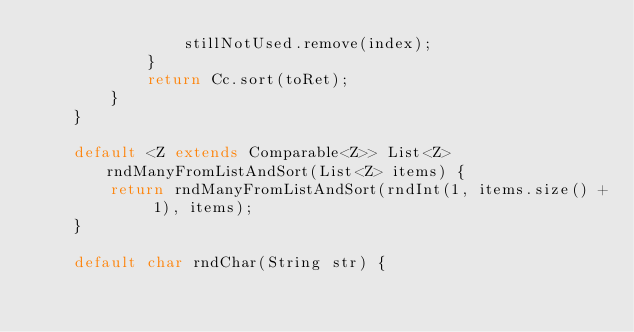<code> <loc_0><loc_0><loc_500><loc_500><_Java_>                stillNotUsed.remove(index);
            }
            return Cc.sort(toRet);
        }
    }

    default <Z extends Comparable<Z>> List<Z> rndManyFromListAndSort(List<Z> items) {
        return rndManyFromListAndSort(rndInt(1, items.size() + 1), items);
    }

    default char rndChar(String str) {</code> 